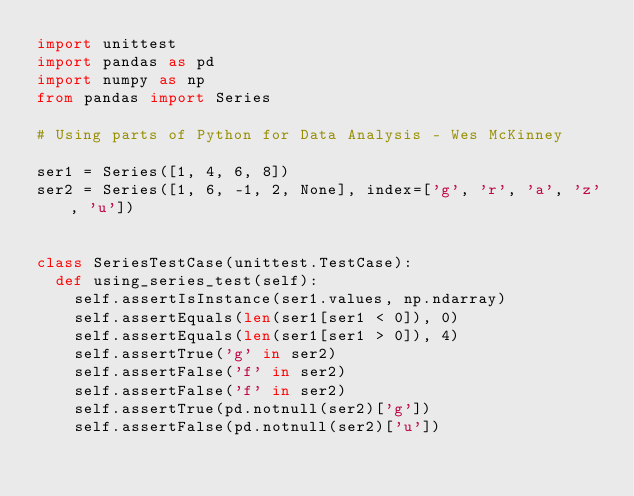Convert code to text. <code><loc_0><loc_0><loc_500><loc_500><_Python_>import unittest
import pandas as pd
import numpy as np
from pandas import Series

# Using parts of Python for Data Analysis - Wes McKinney

ser1 = Series([1, 4, 6, 8])
ser2 = Series([1, 6, -1, 2, None], index=['g', 'r', 'a', 'z', 'u'])


class SeriesTestCase(unittest.TestCase):
  def using_series_test(self):
    self.assertIsInstance(ser1.values, np.ndarray)
    self.assertEquals(len(ser1[ser1 < 0]), 0)
    self.assertEquals(len(ser1[ser1 > 0]), 4)
    self.assertTrue('g' in ser2)
    self.assertFalse('f' in ser2)
    self.assertFalse('f' in ser2)
    self.assertTrue(pd.notnull(ser2)['g'])
    self.assertFalse(pd.notnull(ser2)['u'])
</code> 